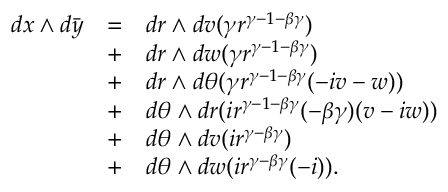Convert formula to latex. <formula><loc_0><loc_0><loc_500><loc_500>\begin{array} { r c l } { d x \wedge d \bar { y } } & { = } & { d r \wedge d v ( \gamma r ^ { \gamma - 1 - \beta \gamma } ) } \\ & { + } & { d r \wedge d w ( \gamma r ^ { \gamma - 1 - \beta \gamma } ) } \\ & { + } & { d r \wedge d \theta ( \gamma r ^ { \gamma - 1 - \beta \gamma } ( - i v - w ) ) } \\ & { + } & { d \theta \wedge d r ( i r ^ { \gamma - 1 - \beta \gamma } ( - \beta \gamma ) ( v - i w ) ) } \\ & { + } & { d \theta \wedge d v ( i r ^ { \gamma - \beta \gamma } ) } \\ & { + } & { d \theta \wedge d w ( i r ^ { \gamma - \beta \gamma } ( - i ) ) . } \end{array}</formula> 